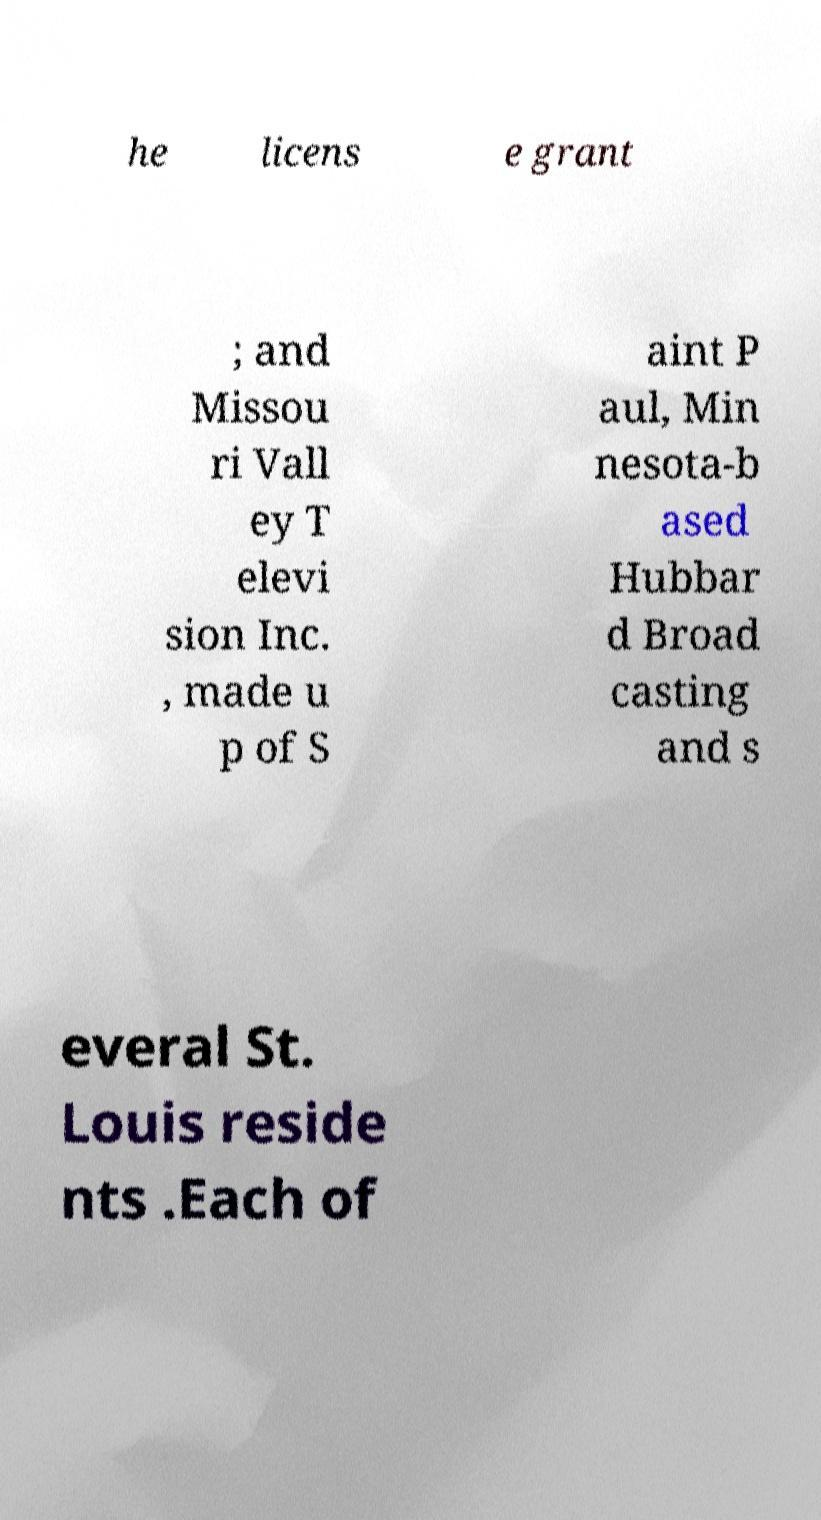Can you read and provide the text displayed in the image?This photo seems to have some interesting text. Can you extract and type it out for me? he licens e grant ; and Missou ri Vall ey T elevi sion Inc. , made u p of S aint P aul, Min nesota-b ased Hubbar d Broad casting and s everal St. Louis reside nts .Each of 